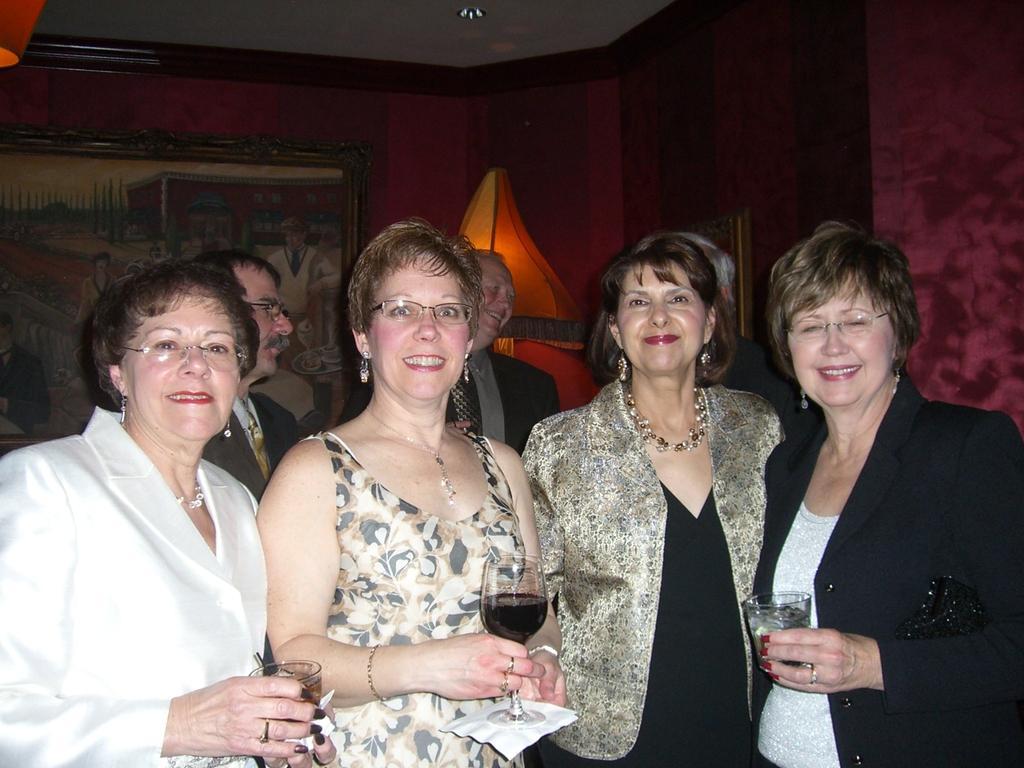How would you summarize this image in a sentence or two? There are four women in different color dresses, standing and smiling. Three of them are holding glasses, which are filled with drink. In the background, there are other persons standing, there is a photo frame on the wall and there are other objects. 